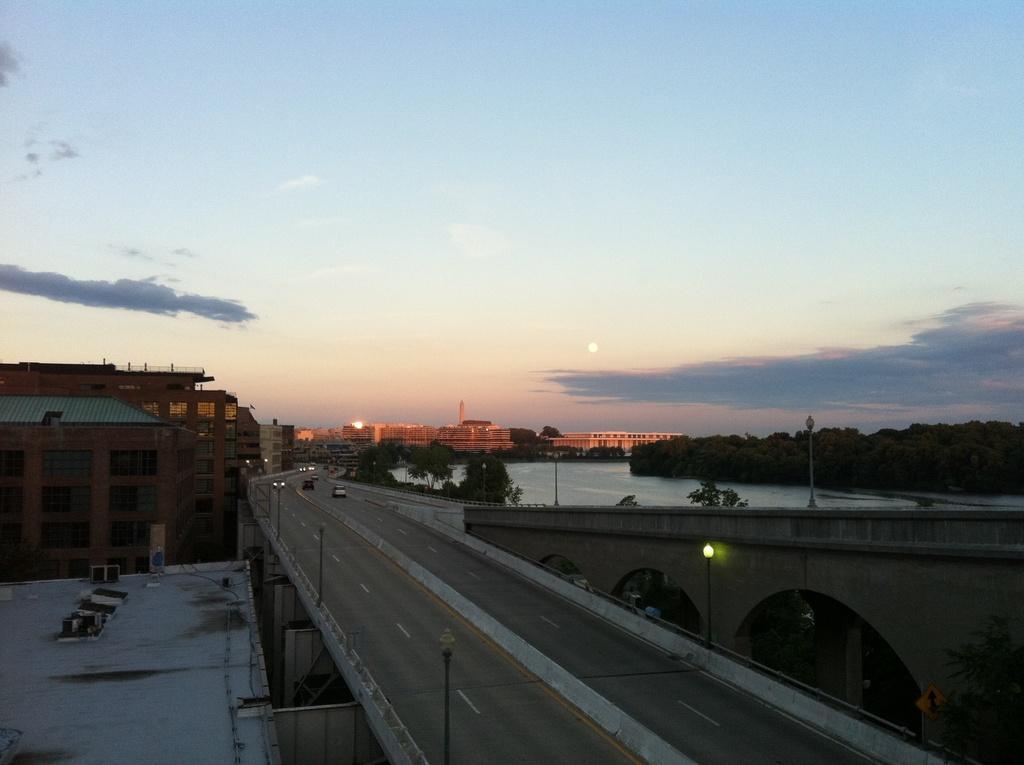Please provide a concise description of this image. This is the picture of a city. There are vehicles on the road. At the back there is a bridge and there are buildings, trees and poles. At the top there is sky and there are clouds and there is a sun. At the bottom there is water. 